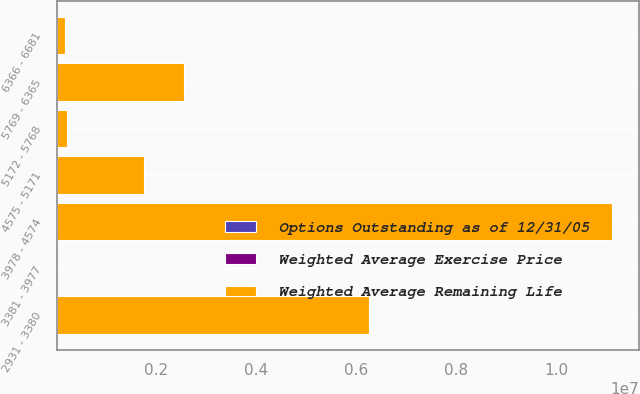<chart> <loc_0><loc_0><loc_500><loc_500><stacked_bar_chart><ecel><fcel>2931 - 3380<fcel>3381 - 3977<fcel>3978 - 4574<fcel>4575 - 5171<fcel>5172 - 5768<fcel>5769 - 6365<fcel>6366 - 6681<nl><fcel>Weighted Average Remaining Life<fcel>6.26447e+06<fcel>44.38<fcel>1.11138e+07<fcel>1.7469e+06<fcel>213192<fcel>2.55009e+06<fcel>178200<nl><fcel>Options Outstanding as of 12/31/05<fcel>5.6<fcel>6.7<fcel>5.9<fcel>2.9<fcel>0.8<fcel>3.8<fcel>4<nl><fcel>Weighted Average Exercise Price<fcel>31.77<fcel>37.25<fcel>41.34<fcel>47.42<fcel>54.23<fcel>59.14<fcel>64.7<nl></chart> 